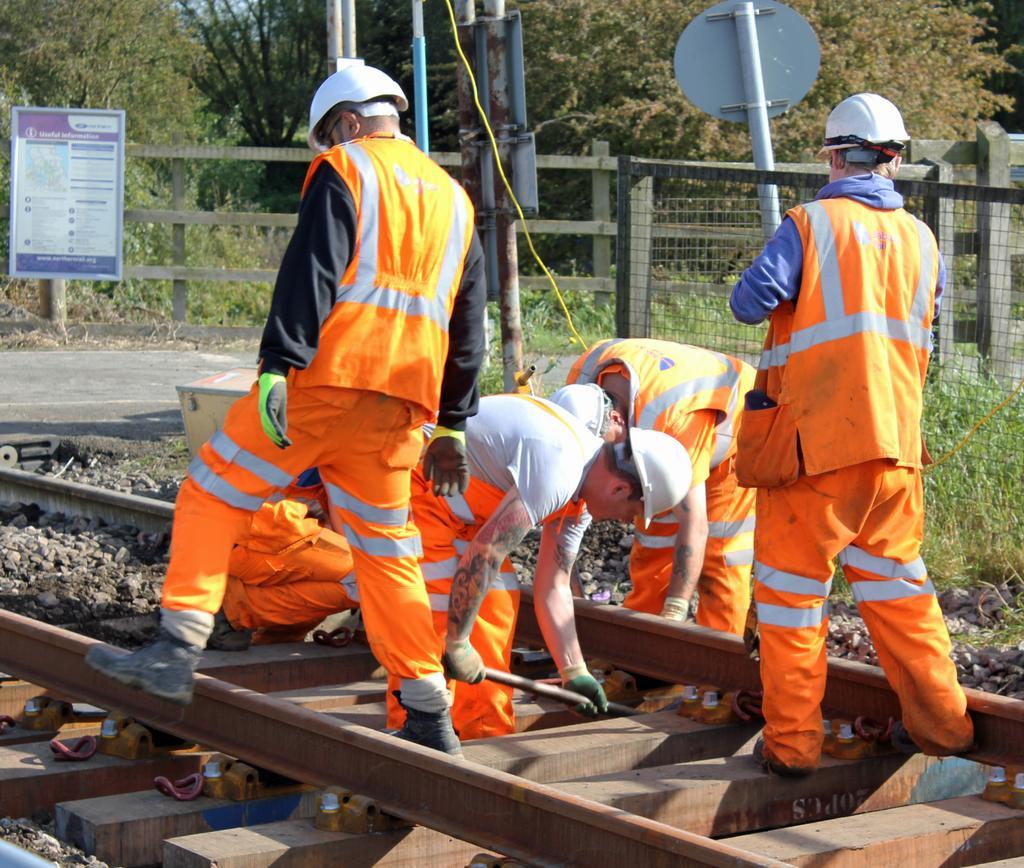In one or two sentences, can you explain what this image depicts? In this image we can see a group of men on the track. In that a man is holding a rod. We can also see some stones, boards, poles, a fence, plants and a group of trees. 